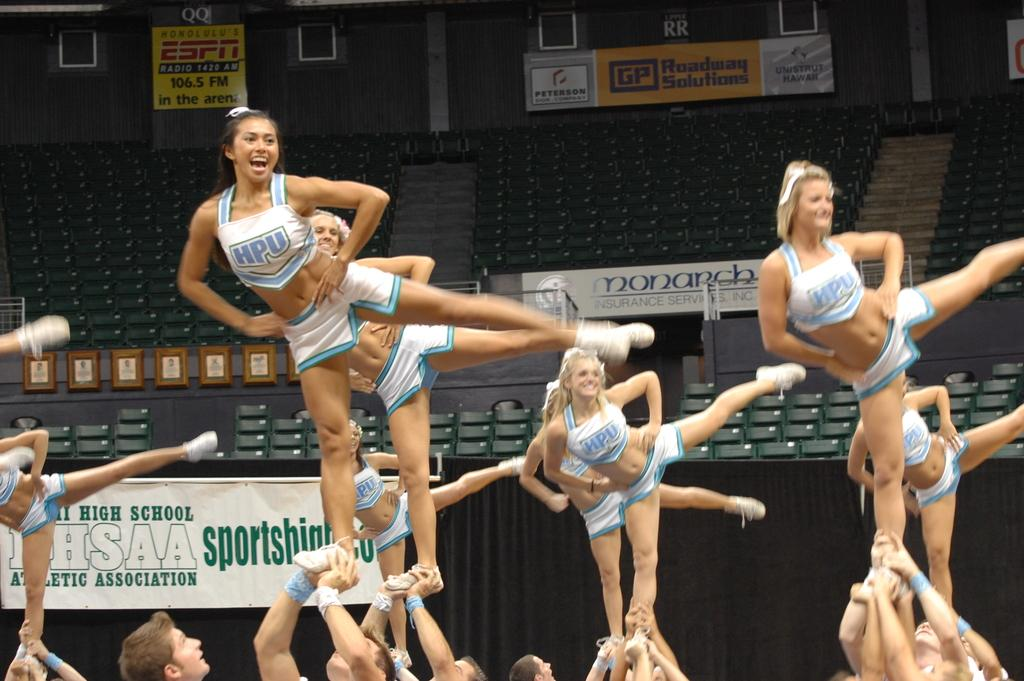<image>
Provide a brief description of the given image. A group of cheerleaders from HPU standing in a formation. 